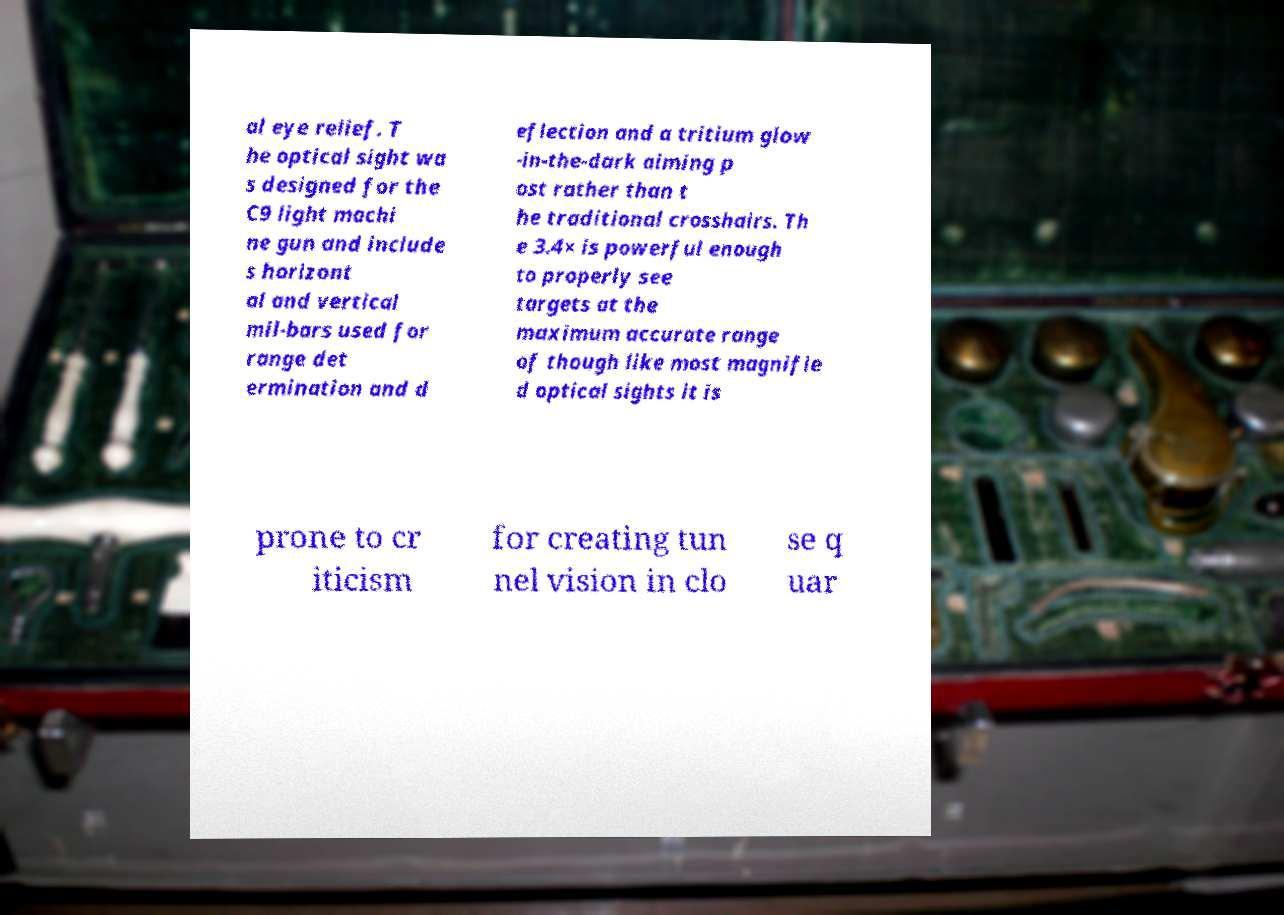Could you extract and type out the text from this image? al eye relief. T he optical sight wa s designed for the C9 light machi ne gun and include s horizont al and vertical mil-bars used for range det ermination and d eflection and a tritium glow -in-the-dark aiming p ost rather than t he traditional crosshairs. Th e 3.4× is powerful enough to properly see targets at the maximum accurate range of though like most magnifie d optical sights it is prone to cr iticism for creating tun nel vision in clo se q uar 